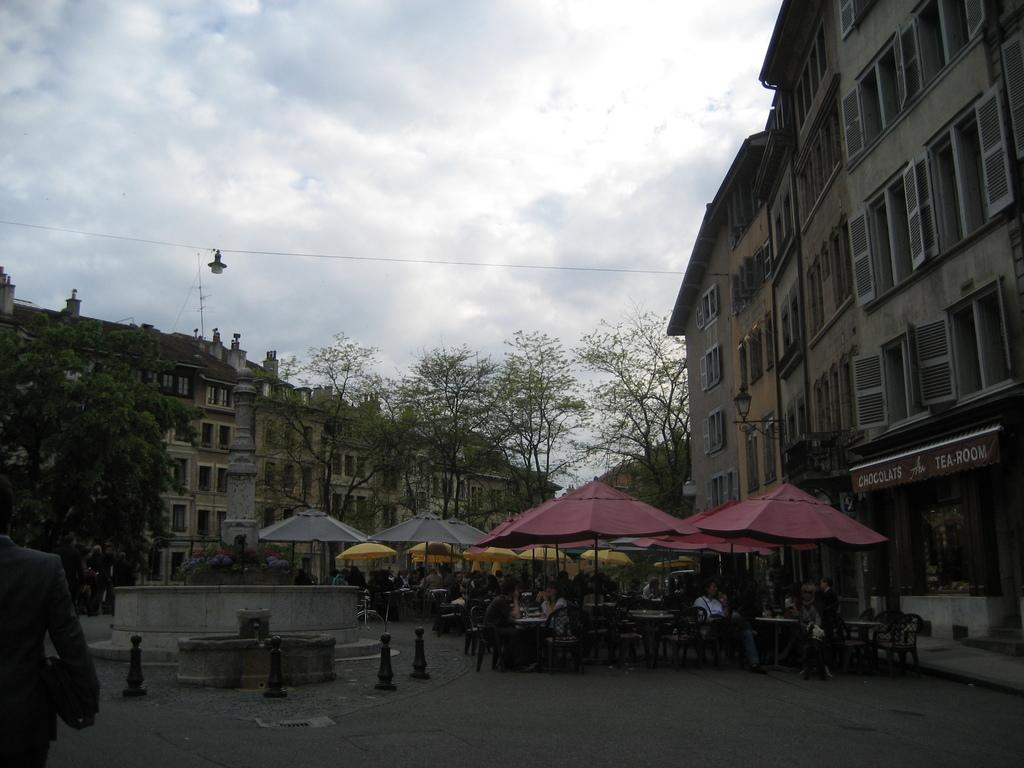What objects are on the right side of the image? There are umbrellas on the right side of the image. What are the people in the image doing? The people are sitting on chairs in the image. What can be seen in the middle of the image? There are trees and buildings in the middle of the image. What is visible at the top of the image? The sky is visible at the top of the image. What type of station is visible in the image? There is no station present in the image. What position do the trees hold in the image? The trees are located in the middle of the image, but they do not hold a position. 